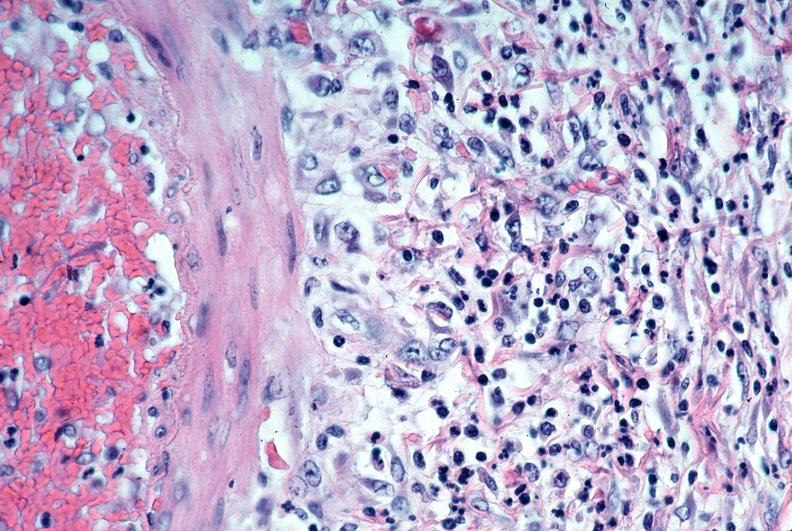s cardiovascular present?
Answer the question using a single word or phrase. Yes 